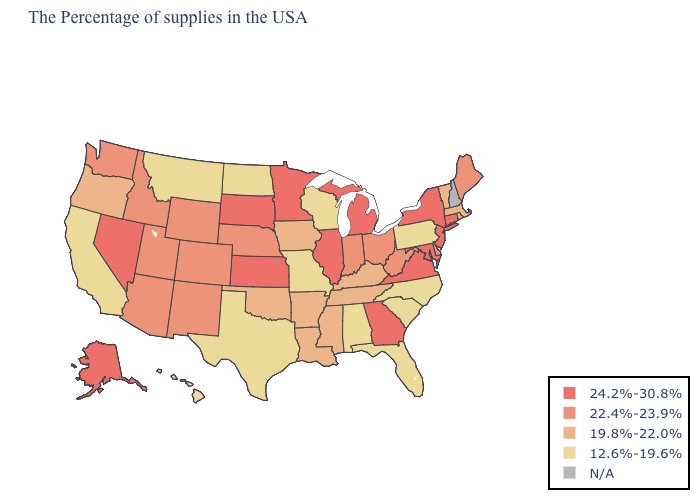What is the highest value in states that border Indiana?
Quick response, please. 24.2%-30.8%. Does Wisconsin have the lowest value in the MidWest?
Keep it brief. Yes. Name the states that have a value in the range N/A?
Give a very brief answer. New Hampshire. What is the lowest value in states that border Iowa?
Keep it brief. 12.6%-19.6%. Does Maine have the lowest value in the USA?
Keep it brief. No. What is the highest value in the Northeast ?
Concise answer only. 24.2%-30.8%. Among the states that border Maryland , which have the highest value?
Short answer required. Virginia. Does Alabama have the lowest value in the South?
Write a very short answer. Yes. Name the states that have a value in the range 24.2%-30.8%?
Give a very brief answer. Connecticut, New York, New Jersey, Maryland, Virginia, Georgia, Michigan, Illinois, Minnesota, Kansas, South Dakota, Nevada, Alaska. Among the states that border Minnesota , which have the highest value?
Give a very brief answer. South Dakota. Does Nevada have the highest value in the West?
Concise answer only. Yes. Name the states that have a value in the range 12.6%-19.6%?
Keep it brief. Pennsylvania, North Carolina, South Carolina, Florida, Alabama, Wisconsin, Missouri, Texas, North Dakota, Montana, California, Hawaii. Does the first symbol in the legend represent the smallest category?
Answer briefly. No. 